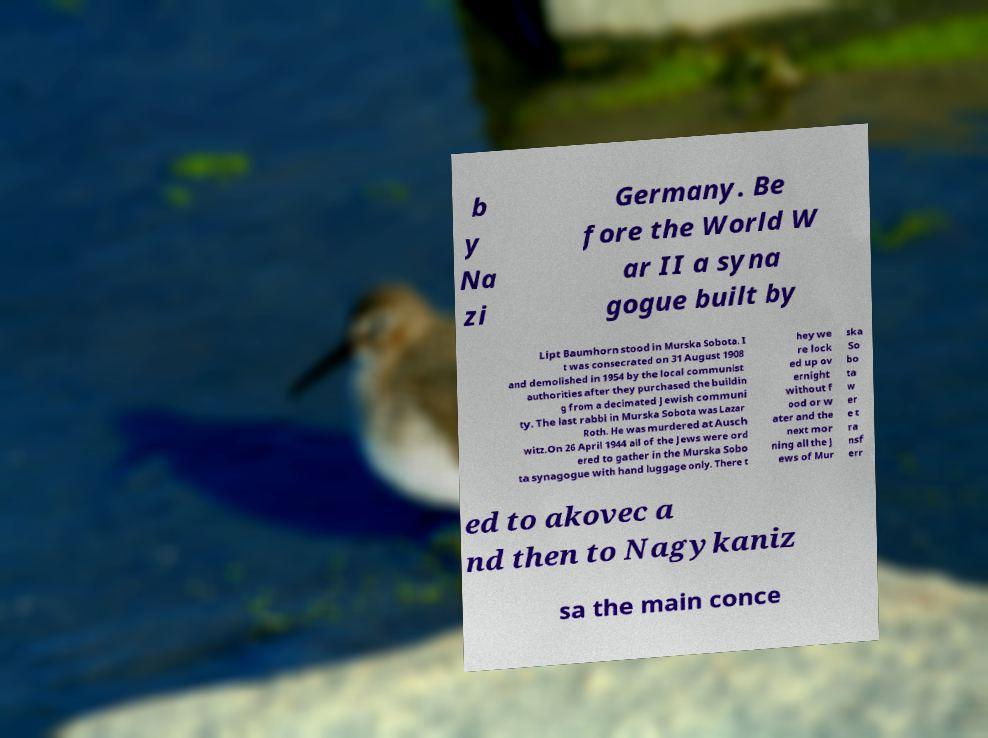Could you extract and type out the text from this image? b y Na zi Germany. Be fore the World W ar II a syna gogue built by Lipt Baumhorn stood in Murska Sobota. I t was consecrated on 31 August 1908 and demolished in 1954 by the local communist authorities after they purchased the buildin g from a decimated Jewish communi ty. The last rabbi in Murska Sobota was Lazar Roth. He was murdered at Ausch witz.On 26 April 1944 all of the Jews were ord ered to gather in the Murska Sobo ta synagogue with hand luggage only. There t hey we re lock ed up ov ernight without f ood or w ater and the next mor ning all the J ews of Mur ska So bo ta w er e t ra nsf err ed to akovec a nd then to Nagykaniz sa the main conce 